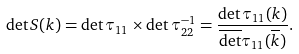Convert formula to latex. <formula><loc_0><loc_0><loc_500><loc_500>\det S ( k ) = \det \tau _ { 1 1 } \times \det \tau _ { 2 2 } ^ { - 1 } = \frac { { \det \tau _ { 1 1 } ( k ) } } { \overline { \det } \tau _ { 1 1 } ( \overline { k } ) } .</formula> 